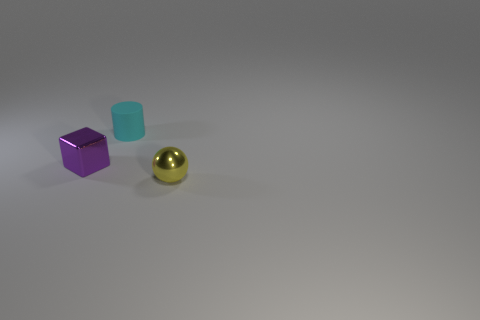Is there any other thing that has the same material as the tiny purple block?
Provide a short and direct response. Yes. Is the number of tiny yellow metallic objects in front of the sphere less than the number of shiny things behind the purple shiny object?
Your answer should be compact. No. What shape is the tiny thing that is behind the yellow metallic sphere and in front of the cyan thing?
Provide a short and direct response. Cube. What size is the yellow sphere that is the same material as the tiny purple object?
Make the answer very short. Small. There is a tiny block; is its color the same as the small object right of the tiny cyan matte cylinder?
Give a very brief answer. No. What is the tiny thing that is both to the right of the purple metallic block and on the left side of the small yellow metallic sphere made of?
Your answer should be very brief. Rubber. Does the thing behind the purple shiny thing have the same shape as the small metal object that is to the right of the small cyan cylinder?
Make the answer very short. No. Are there any balls?
Offer a terse response. Yes. What color is the rubber object that is the same size as the purple cube?
Provide a succinct answer. Cyan. Do the small cylinder and the tiny yellow thing have the same material?
Provide a short and direct response. No. 